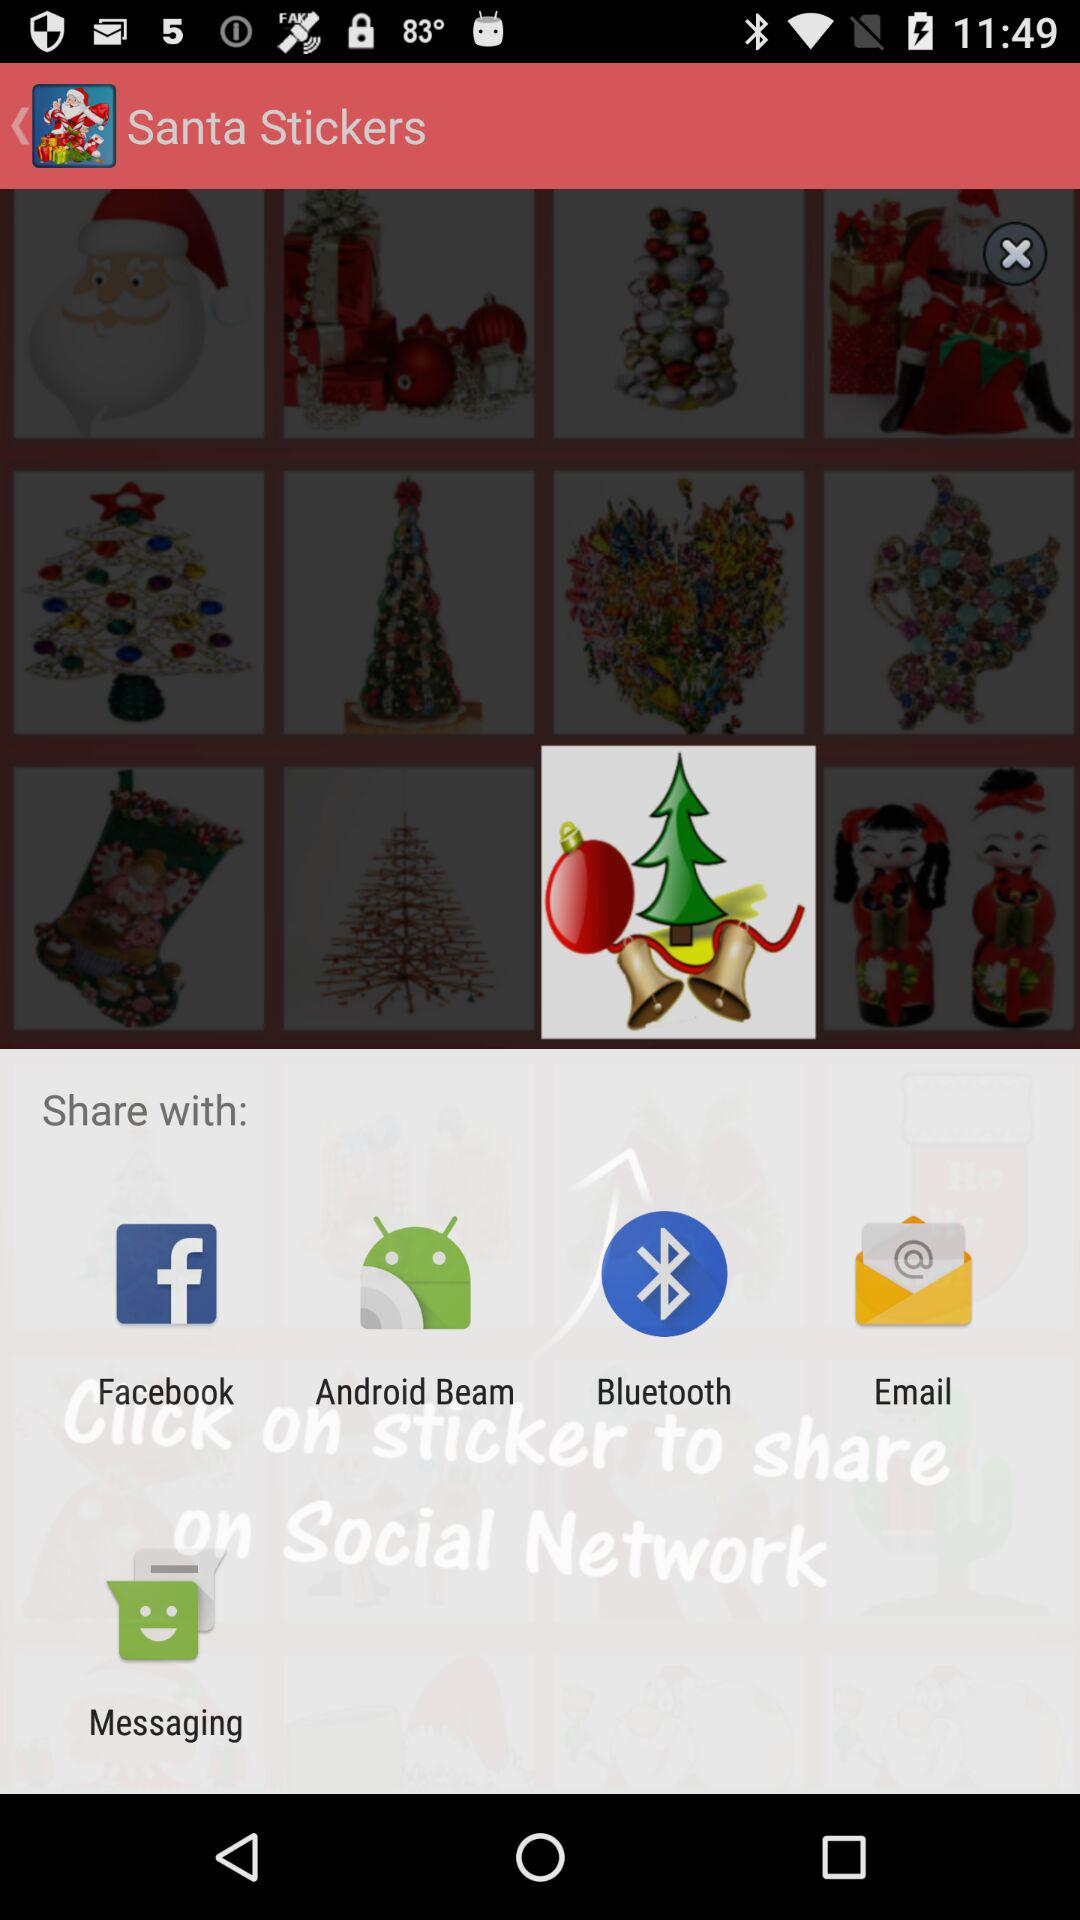What are the options available for sharing? The options available are "Facebook", "Android Beam", "Bluetooth", "Email" and "Messaging". 